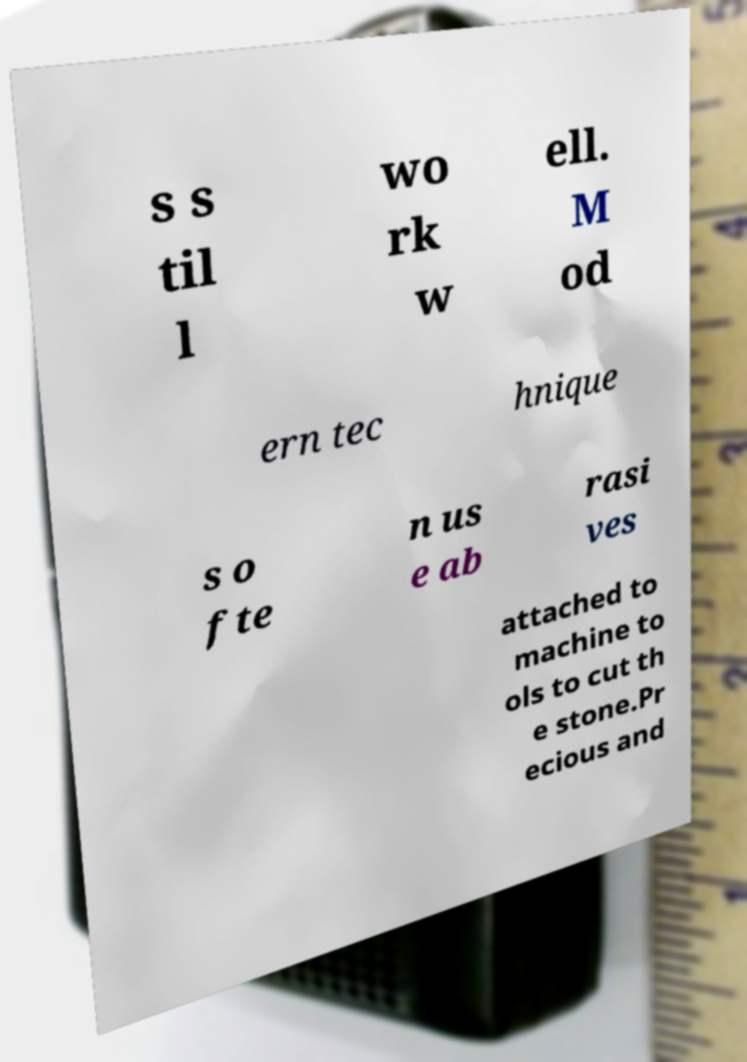For documentation purposes, I need the text within this image transcribed. Could you provide that? s s til l wo rk w ell. M od ern tec hnique s o fte n us e ab rasi ves attached to machine to ols to cut th e stone.Pr ecious and 